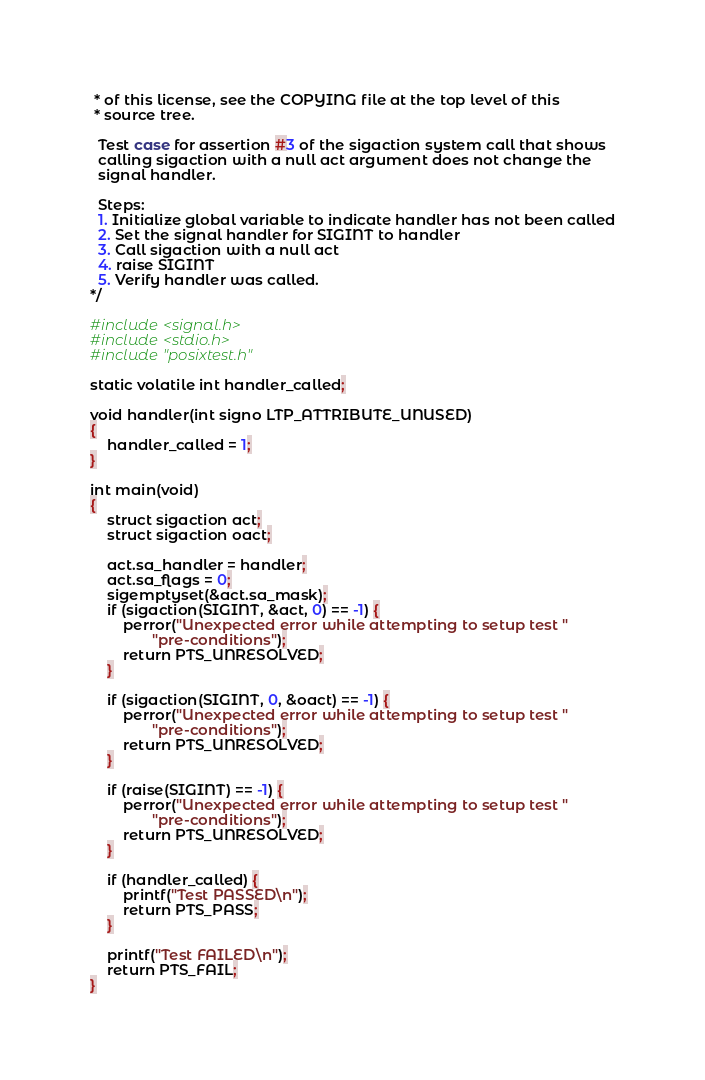<code> <loc_0><loc_0><loc_500><loc_500><_C_> * of this license, see the COPYING file at the top level of this
 * source tree.

  Test case for assertion #3 of the sigaction system call that shows
  calling sigaction with a null act argument does not change the
  signal handler.

  Steps:
  1. Initialize global variable to indicate handler has not been called
  2. Set the signal handler for SIGINT to handler
  3. Call sigaction with a null act
  4. raise SIGINT
  5. Verify handler was called.
*/

#include <signal.h>
#include <stdio.h>
#include "posixtest.h"

static volatile int handler_called;

void handler(int signo LTP_ATTRIBUTE_UNUSED)
{
	handler_called = 1;
}

int main(void)
{
	struct sigaction act;
	struct sigaction oact;

	act.sa_handler = handler;
	act.sa_flags = 0;
	sigemptyset(&act.sa_mask);
	if (sigaction(SIGINT, &act, 0) == -1) {
		perror("Unexpected error while attempting to setup test "
		       "pre-conditions");
		return PTS_UNRESOLVED;
	}

	if (sigaction(SIGINT, 0, &oact) == -1) {
		perror("Unexpected error while attempting to setup test "
		       "pre-conditions");
		return PTS_UNRESOLVED;
	}

	if (raise(SIGINT) == -1) {
		perror("Unexpected error while attempting to setup test "
		       "pre-conditions");
		return PTS_UNRESOLVED;
	}

	if (handler_called) {
		printf("Test PASSED\n");
		return PTS_PASS;
	}

	printf("Test FAILED\n");
	return PTS_FAIL;
}
</code> 